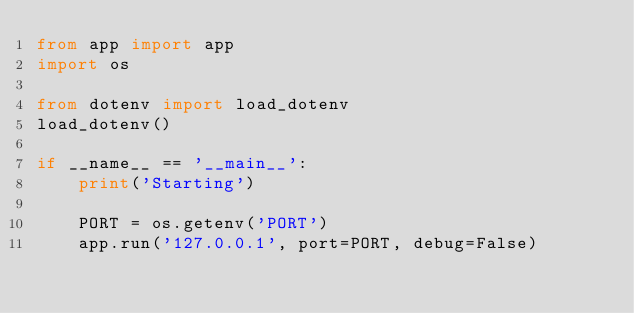<code> <loc_0><loc_0><loc_500><loc_500><_Python_>from app import app
import os

from dotenv import load_dotenv
load_dotenv()

if __name__ == '__main__':
    print('Starting')

    PORT = os.getenv('PORT')
    app.run('127.0.0.1', port=PORT, debug=False)
    
</code> 